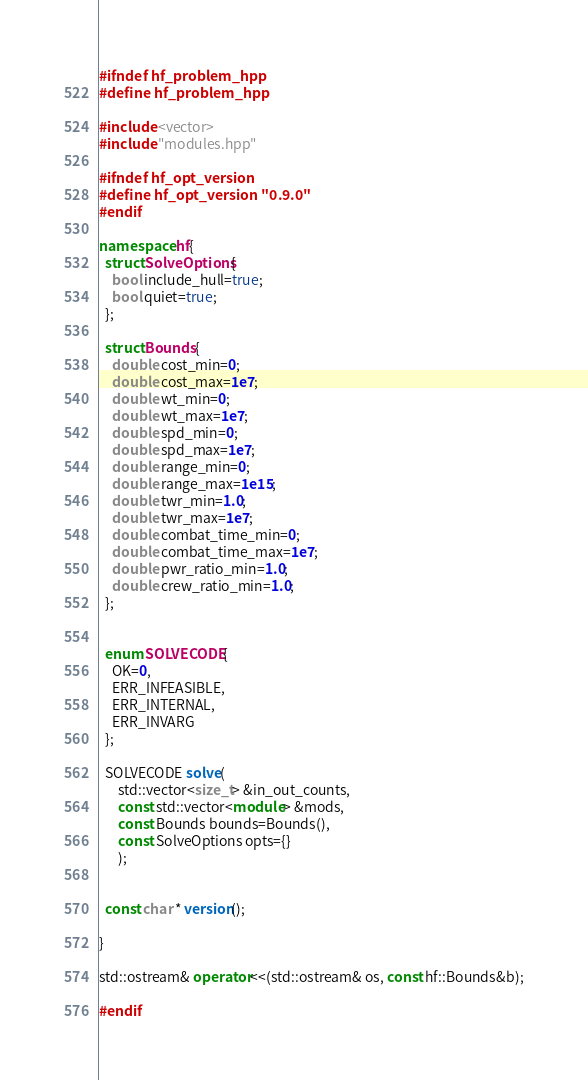Convert code to text. <code><loc_0><loc_0><loc_500><loc_500><_C++_>#ifndef hf_problem_hpp
#define hf_problem_hpp

#include <vector>
#include "modules.hpp"

#ifndef hf_opt_version
#define hf_opt_version "0.9.0"
#endif

namespace hf{
  struct SolveOptions{
    bool include_hull=true;
    bool quiet=true;
  };

  struct Bounds{
    double cost_min=0;
    double cost_max=1e7;
    double wt_min=0;
    double wt_max=1e7;
    double spd_min=0;
    double spd_max=1e7;
    double range_min=0;
    double range_max=1e15;
    double twr_min=1.0;
    double twr_max=1e7;
    double combat_time_min=0;
    double combat_time_max=1e7;
    double pwr_ratio_min=1.0;
    double crew_ratio_min=1.0;
  };


  enum SOLVECODE{
    OK=0,
    ERR_INFEASIBLE,
    ERR_INTERNAL,
    ERR_INVARG
  };

  SOLVECODE solve(
      std::vector<size_t> &in_out_counts,
      const std::vector<module> &mods,
      const Bounds bounds=Bounds(),
      const SolveOptions opts={}
      );


  const char * version();

}

std::ostream& operator<<(std::ostream& os, const hf::Bounds&b);

#endif
</code> 